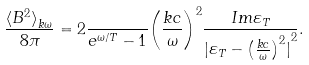Convert formula to latex. <formula><loc_0><loc_0><loc_500><loc_500>\frac { { \langle B ^ { 2 } \rangle } _ { { k } { \omega } } } { 8 \pi } = 2 \frac { } { e ^ { { } { \omega } / T } - 1 } { \left ( \frac { k c } { \omega } \right ) } ^ { 2 } \frac { I m { \varepsilon } _ { T } } { { | { \varepsilon } _ { T } - { \left ( \frac { k c } { \omega } \right ) } ^ { 2 } | } ^ { 2 } } .</formula> 